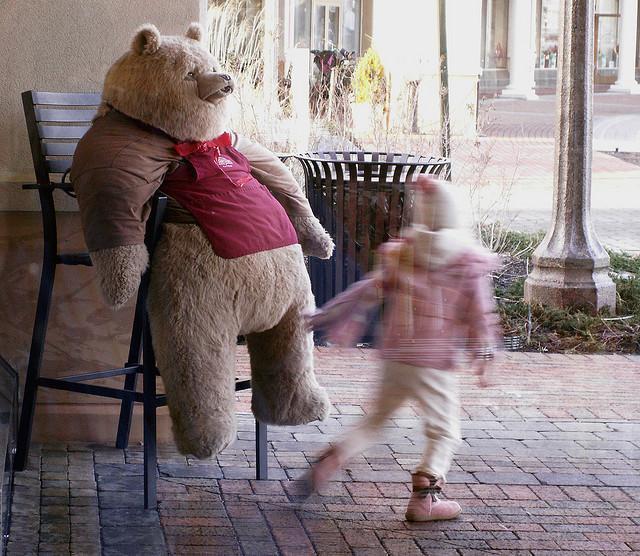How many overstuffed, large bears?
Give a very brief answer. 1. 